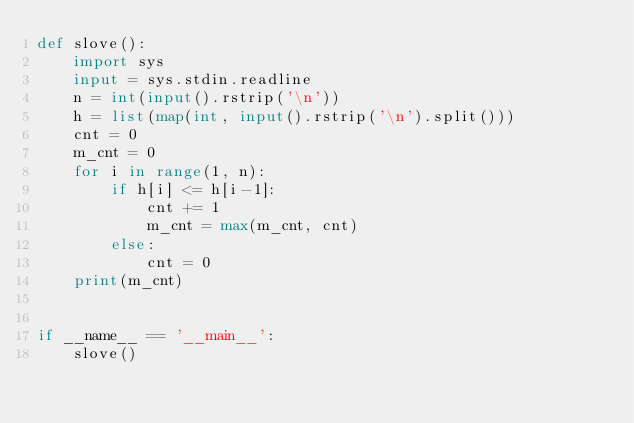Convert code to text. <code><loc_0><loc_0><loc_500><loc_500><_Python_>def slove():
    import sys
    input = sys.stdin.readline
    n = int(input().rstrip('\n'))
    h = list(map(int, input().rstrip('\n').split()))
    cnt = 0
    m_cnt = 0
    for i in range(1, n):
        if h[i] <= h[i-1]:
            cnt += 1
            m_cnt = max(m_cnt, cnt)
        else:
            cnt = 0
    print(m_cnt)


if __name__ == '__main__':
    slove()
</code> 